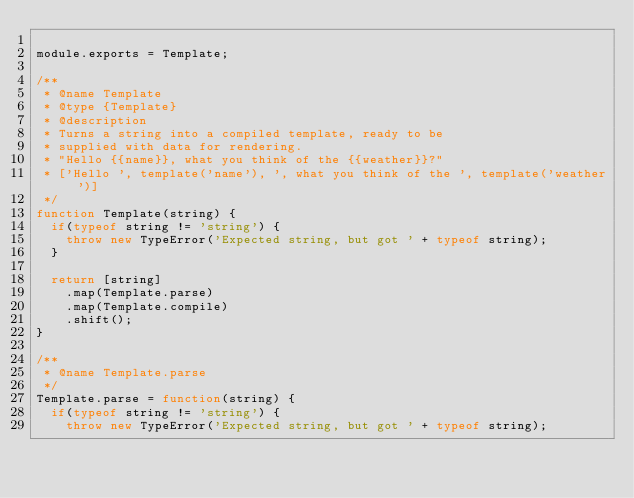Convert code to text. <code><loc_0><loc_0><loc_500><loc_500><_JavaScript_>
module.exports = Template;

/**
 * @name Template
 * @type {Template}
 * @description
 * Turns a string into a compiled template, ready to be
 * supplied with data for rendering.
 * "Hello {{name}}, what you think of the {{weather}}?"
 * ['Hello ', template('name'), ', what you think of the ', template('weather')]
 */
function Template(string) {
  if(typeof string != 'string') {
    throw new TypeError('Expected string, but got ' + typeof string);
  }

  return [string]
    .map(Template.parse)
    .map(Template.compile)
    .shift();
}

/**
 * @name Template.parse
 */
Template.parse = function(string) {
  if(typeof string != 'string') {
    throw new TypeError('Expected string, but got ' + typeof string);</code> 